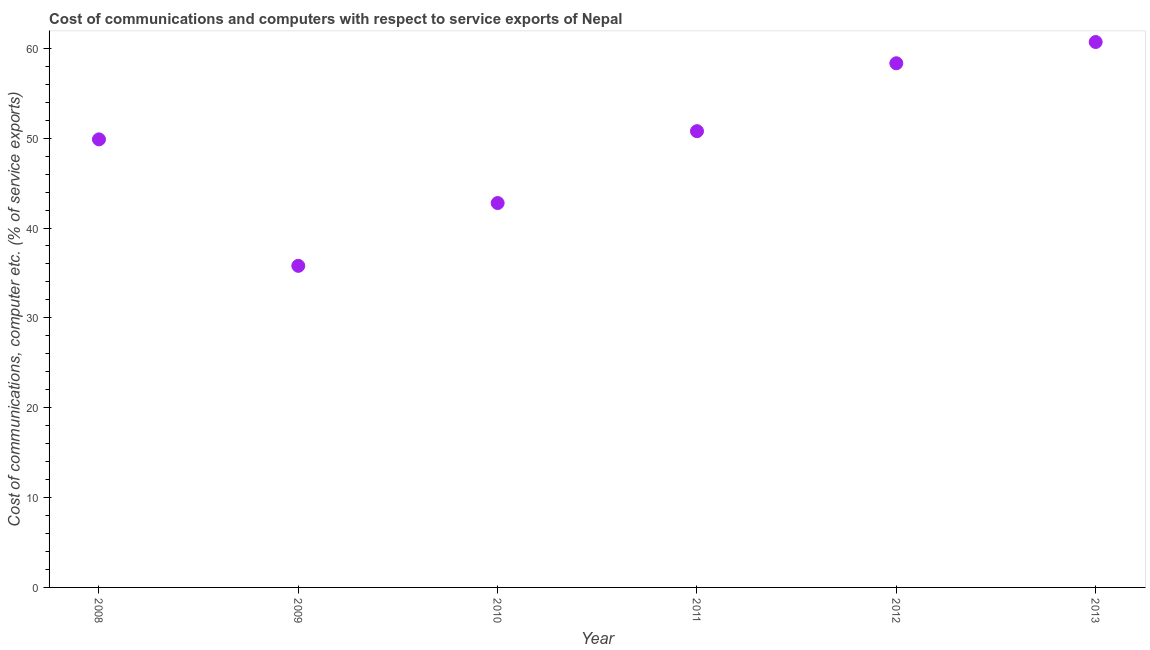What is the cost of communications and computer in 2011?
Offer a terse response. 50.78. Across all years, what is the maximum cost of communications and computer?
Offer a very short reply. 60.7. Across all years, what is the minimum cost of communications and computer?
Make the answer very short. 35.79. What is the sum of the cost of communications and computer?
Keep it short and to the point. 298.24. What is the difference between the cost of communications and computer in 2011 and 2013?
Give a very brief answer. -9.92. What is the average cost of communications and computer per year?
Your answer should be compact. 49.71. What is the median cost of communications and computer?
Give a very brief answer. 50.32. Do a majority of the years between 2013 and 2010 (inclusive) have cost of communications and computer greater than 54 %?
Provide a succinct answer. Yes. What is the ratio of the cost of communications and computer in 2008 to that in 2009?
Offer a very short reply. 1.39. Is the cost of communications and computer in 2009 less than that in 2012?
Provide a succinct answer. Yes. Is the difference between the cost of communications and computer in 2011 and 2012 greater than the difference between any two years?
Offer a very short reply. No. What is the difference between the highest and the second highest cost of communications and computer?
Give a very brief answer. 2.36. What is the difference between the highest and the lowest cost of communications and computer?
Offer a terse response. 24.91. How many dotlines are there?
Your answer should be compact. 1. Does the graph contain any zero values?
Provide a succinct answer. No. What is the title of the graph?
Ensure brevity in your answer.  Cost of communications and computers with respect to service exports of Nepal. What is the label or title of the Y-axis?
Offer a very short reply. Cost of communications, computer etc. (% of service exports). What is the Cost of communications, computer etc. (% of service exports) in 2008?
Your answer should be compact. 49.86. What is the Cost of communications, computer etc. (% of service exports) in 2009?
Keep it short and to the point. 35.79. What is the Cost of communications, computer etc. (% of service exports) in 2010?
Your answer should be very brief. 42.78. What is the Cost of communications, computer etc. (% of service exports) in 2011?
Ensure brevity in your answer.  50.78. What is the Cost of communications, computer etc. (% of service exports) in 2012?
Your answer should be compact. 58.33. What is the Cost of communications, computer etc. (% of service exports) in 2013?
Provide a succinct answer. 60.7. What is the difference between the Cost of communications, computer etc. (% of service exports) in 2008 and 2009?
Offer a very short reply. 14.07. What is the difference between the Cost of communications, computer etc. (% of service exports) in 2008 and 2010?
Provide a short and direct response. 7.09. What is the difference between the Cost of communications, computer etc. (% of service exports) in 2008 and 2011?
Keep it short and to the point. -0.91. What is the difference between the Cost of communications, computer etc. (% of service exports) in 2008 and 2012?
Keep it short and to the point. -8.47. What is the difference between the Cost of communications, computer etc. (% of service exports) in 2008 and 2013?
Offer a terse response. -10.84. What is the difference between the Cost of communications, computer etc. (% of service exports) in 2009 and 2010?
Your answer should be very brief. -6.99. What is the difference between the Cost of communications, computer etc. (% of service exports) in 2009 and 2011?
Your answer should be very brief. -14.99. What is the difference between the Cost of communications, computer etc. (% of service exports) in 2009 and 2012?
Your answer should be compact. -22.55. What is the difference between the Cost of communications, computer etc. (% of service exports) in 2009 and 2013?
Your answer should be compact. -24.91. What is the difference between the Cost of communications, computer etc. (% of service exports) in 2010 and 2011?
Provide a short and direct response. -8. What is the difference between the Cost of communications, computer etc. (% of service exports) in 2010 and 2012?
Your answer should be very brief. -15.56. What is the difference between the Cost of communications, computer etc. (% of service exports) in 2010 and 2013?
Give a very brief answer. -17.92. What is the difference between the Cost of communications, computer etc. (% of service exports) in 2011 and 2012?
Offer a terse response. -7.56. What is the difference between the Cost of communications, computer etc. (% of service exports) in 2011 and 2013?
Make the answer very short. -9.92. What is the difference between the Cost of communications, computer etc. (% of service exports) in 2012 and 2013?
Your answer should be very brief. -2.36. What is the ratio of the Cost of communications, computer etc. (% of service exports) in 2008 to that in 2009?
Your response must be concise. 1.39. What is the ratio of the Cost of communications, computer etc. (% of service exports) in 2008 to that in 2010?
Make the answer very short. 1.17. What is the ratio of the Cost of communications, computer etc. (% of service exports) in 2008 to that in 2011?
Ensure brevity in your answer.  0.98. What is the ratio of the Cost of communications, computer etc. (% of service exports) in 2008 to that in 2012?
Ensure brevity in your answer.  0.85. What is the ratio of the Cost of communications, computer etc. (% of service exports) in 2008 to that in 2013?
Give a very brief answer. 0.82. What is the ratio of the Cost of communications, computer etc. (% of service exports) in 2009 to that in 2010?
Your answer should be compact. 0.84. What is the ratio of the Cost of communications, computer etc. (% of service exports) in 2009 to that in 2011?
Ensure brevity in your answer.  0.7. What is the ratio of the Cost of communications, computer etc. (% of service exports) in 2009 to that in 2012?
Keep it short and to the point. 0.61. What is the ratio of the Cost of communications, computer etc. (% of service exports) in 2009 to that in 2013?
Offer a terse response. 0.59. What is the ratio of the Cost of communications, computer etc. (% of service exports) in 2010 to that in 2011?
Keep it short and to the point. 0.84. What is the ratio of the Cost of communications, computer etc. (% of service exports) in 2010 to that in 2012?
Provide a succinct answer. 0.73. What is the ratio of the Cost of communications, computer etc. (% of service exports) in 2010 to that in 2013?
Your answer should be compact. 0.7. What is the ratio of the Cost of communications, computer etc. (% of service exports) in 2011 to that in 2012?
Your answer should be compact. 0.87. What is the ratio of the Cost of communications, computer etc. (% of service exports) in 2011 to that in 2013?
Provide a succinct answer. 0.84. 